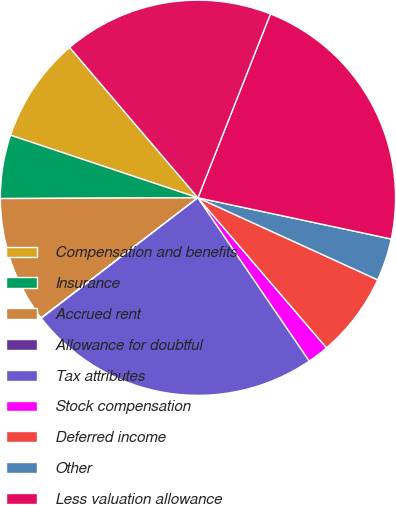<chart> <loc_0><loc_0><loc_500><loc_500><pie_chart><fcel>Compensation and benefits<fcel>Insurance<fcel>Accrued rent<fcel>Allowance for doubtful<fcel>Tax attributes<fcel>Stock compensation<fcel>Deferred income<fcel>Other<fcel>Less valuation allowance<fcel>Total deferred tax assets<nl><fcel>8.63%<fcel>5.19%<fcel>10.34%<fcel>0.03%<fcel>24.09%<fcel>1.75%<fcel>6.91%<fcel>3.47%<fcel>22.37%<fcel>17.22%<nl></chart> 